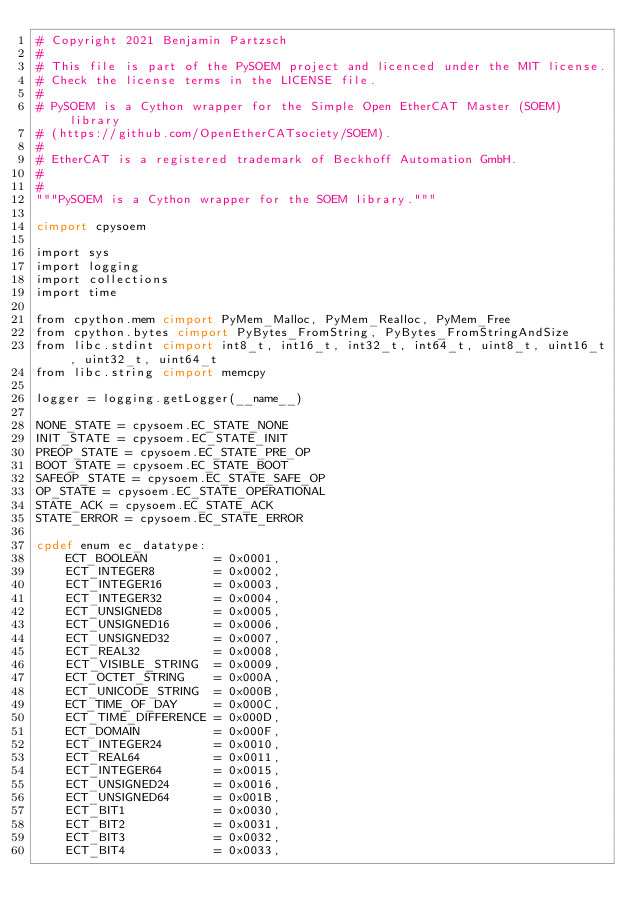Convert code to text. <code><loc_0><loc_0><loc_500><loc_500><_Cython_># Copyright 2021 Benjamin Partzsch
#
# This file is part of the PySOEM project and licenced under the MIT license.
# Check the license terms in the LICENSE file.
#
# PySOEM is a Cython wrapper for the Simple Open EtherCAT Master (SOEM) library
# (https://github.com/OpenEtherCATsociety/SOEM).
#
# EtherCAT is a registered trademark of Beckhoff Automation GmbH.
#
#
"""PySOEM is a Cython wrapper for the SOEM library."""

cimport cpysoem

import sys
import logging
import collections
import time

from cpython.mem cimport PyMem_Malloc, PyMem_Realloc, PyMem_Free
from cpython.bytes cimport PyBytes_FromString, PyBytes_FromStringAndSize
from libc.stdint cimport int8_t, int16_t, int32_t, int64_t, uint8_t, uint16_t, uint32_t, uint64_t
from libc.string cimport memcpy

logger = logging.getLogger(__name__)

NONE_STATE = cpysoem.EC_STATE_NONE
INIT_STATE = cpysoem.EC_STATE_INIT
PREOP_STATE = cpysoem.EC_STATE_PRE_OP
BOOT_STATE = cpysoem.EC_STATE_BOOT
SAFEOP_STATE = cpysoem.EC_STATE_SAFE_OP
OP_STATE = cpysoem.EC_STATE_OPERATIONAL
STATE_ACK = cpysoem.EC_STATE_ACK
STATE_ERROR = cpysoem.EC_STATE_ERROR

cpdef enum ec_datatype:
    ECT_BOOLEAN         = 0x0001,
    ECT_INTEGER8        = 0x0002,
    ECT_INTEGER16       = 0x0003,
    ECT_INTEGER32       = 0x0004,
    ECT_UNSIGNED8       = 0x0005,
    ECT_UNSIGNED16      = 0x0006,
    ECT_UNSIGNED32      = 0x0007,
    ECT_REAL32          = 0x0008,
    ECT_VISIBLE_STRING  = 0x0009,
    ECT_OCTET_STRING    = 0x000A,
    ECT_UNICODE_STRING  = 0x000B,
    ECT_TIME_OF_DAY     = 0x000C,
    ECT_TIME_DIFFERENCE = 0x000D,
    ECT_DOMAIN          = 0x000F,
    ECT_INTEGER24       = 0x0010,
    ECT_REAL64          = 0x0011,
    ECT_INTEGER64       = 0x0015,
    ECT_UNSIGNED24      = 0x0016,
    ECT_UNSIGNED64      = 0x001B,
    ECT_BIT1            = 0x0030,
    ECT_BIT2            = 0x0031,
    ECT_BIT3            = 0x0032,
    ECT_BIT4            = 0x0033,</code> 